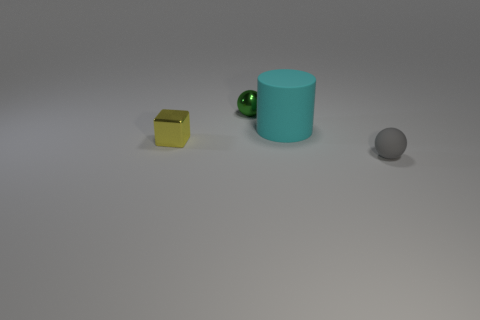Add 1 purple shiny balls. How many objects exist? 5 Subtract 2 spheres. How many spheres are left? 0 Subtract all cylinders. How many objects are left? 3 Add 4 gray matte spheres. How many gray matte spheres exist? 5 Subtract 0 blue spheres. How many objects are left? 4 Subtract all red cylinders. Subtract all red spheres. How many cylinders are left? 1 Subtract all gray metal blocks. Subtract all cyan things. How many objects are left? 3 Add 2 tiny yellow metal objects. How many tiny yellow metal objects are left? 3 